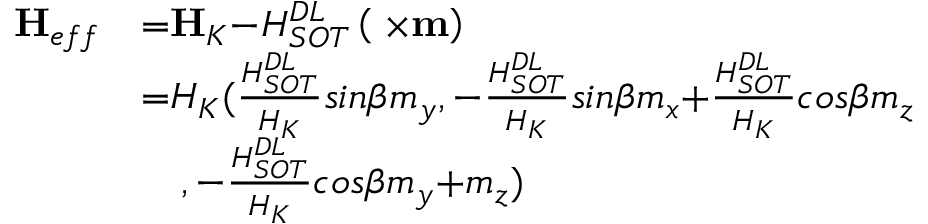<formula> <loc_0><loc_0><loc_500><loc_500>\begin{array} { l l } { { H } _ { e f f } } & { { = } { H } _ { K } { - } H _ { S O T } ^ { D L } \left ( { \sigma } { \times } { m } \right ) } \\ & { { = } H _ { K } ( \frac { H _ { S O T } ^ { D L } } { H _ { K } } { \sin } \beta m _ { y } { , - } \frac { H _ { S O T } ^ { D L } } { H _ { K } } { \sin } \beta m _ { x } { + } \frac { H _ { S O T } ^ { D L } } { H _ { K } } { \cos } \beta m _ { z } } \\ & { \quad , - \frac { H _ { S O T } ^ { D L } } { H _ { K } } { \cos } \beta m _ { y } { + } m _ { z } ) } \end{array}</formula> 